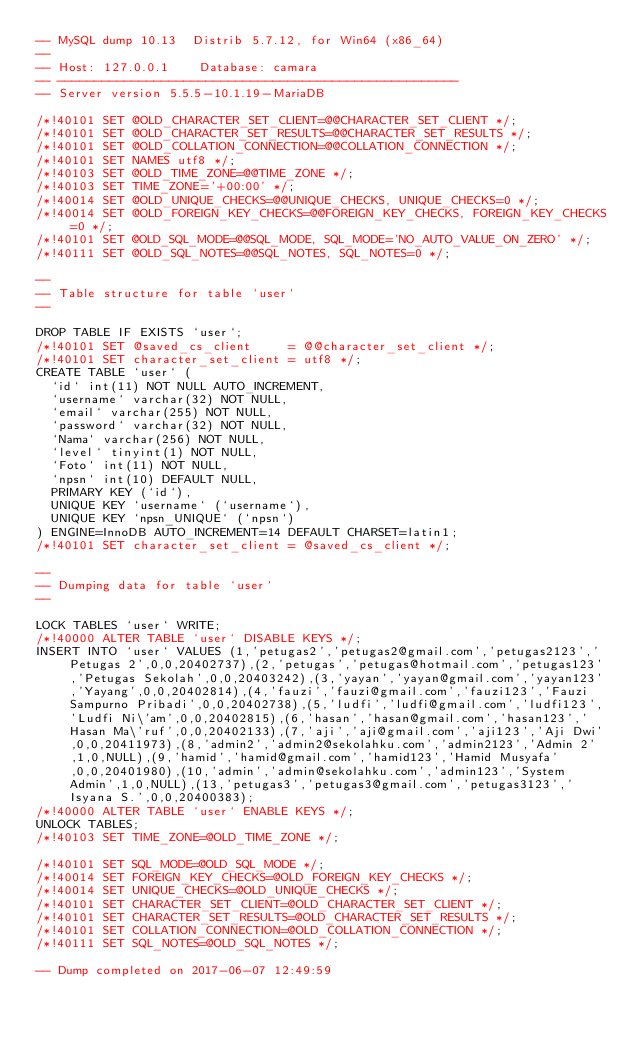<code> <loc_0><loc_0><loc_500><loc_500><_SQL_>-- MySQL dump 10.13  Distrib 5.7.12, for Win64 (x86_64)
--
-- Host: 127.0.0.1    Database: camara
-- ------------------------------------------------------
-- Server version	5.5.5-10.1.19-MariaDB

/*!40101 SET @OLD_CHARACTER_SET_CLIENT=@@CHARACTER_SET_CLIENT */;
/*!40101 SET @OLD_CHARACTER_SET_RESULTS=@@CHARACTER_SET_RESULTS */;
/*!40101 SET @OLD_COLLATION_CONNECTION=@@COLLATION_CONNECTION */;
/*!40101 SET NAMES utf8 */;
/*!40103 SET @OLD_TIME_ZONE=@@TIME_ZONE */;
/*!40103 SET TIME_ZONE='+00:00' */;
/*!40014 SET @OLD_UNIQUE_CHECKS=@@UNIQUE_CHECKS, UNIQUE_CHECKS=0 */;
/*!40014 SET @OLD_FOREIGN_KEY_CHECKS=@@FOREIGN_KEY_CHECKS, FOREIGN_KEY_CHECKS=0 */;
/*!40101 SET @OLD_SQL_MODE=@@SQL_MODE, SQL_MODE='NO_AUTO_VALUE_ON_ZERO' */;
/*!40111 SET @OLD_SQL_NOTES=@@SQL_NOTES, SQL_NOTES=0 */;

--
-- Table structure for table `user`
--

DROP TABLE IF EXISTS `user`;
/*!40101 SET @saved_cs_client     = @@character_set_client */;
/*!40101 SET character_set_client = utf8 */;
CREATE TABLE `user` (
  `id` int(11) NOT NULL AUTO_INCREMENT,
  `username` varchar(32) NOT NULL,
  `email` varchar(255) NOT NULL,
  `password` varchar(32) NOT NULL,
  `Nama` varchar(256) NOT NULL,
  `level` tinyint(1) NOT NULL,
  `Foto` int(11) NOT NULL,
  `npsn` int(10) DEFAULT NULL,
  PRIMARY KEY (`id`),
  UNIQUE KEY `username` (`username`),
  UNIQUE KEY `npsn_UNIQUE` (`npsn`)
) ENGINE=InnoDB AUTO_INCREMENT=14 DEFAULT CHARSET=latin1;
/*!40101 SET character_set_client = @saved_cs_client */;

--
-- Dumping data for table `user`
--

LOCK TABLES `user` WRITE;
/*!40000 ALTER TABLE `user` DISABLE KEYS */;
INSERT INTO `user` VALUES (1,'petugas2','petugas2@gmail.com','petugas2123','Petugas 2',0,0,20402737),(2,'petugas','petugas@hotmail.com','petugas123','Petugas Sekolah',0,0,20403242),(3,'yayan','yayan@gmail.com','yayan123','Yayang',0,0,20402814),(4,'fauzi','fauzi@gmail.com','fauzi123','Fauzi Sampurno Pribadi',0,0,20402738),(5,'ludfi','ludfi@gmail.com','ludfi123','Ludfi Ni\'am',0,0,20402815),(6,'hasan','hasan@gmail.com','hasan123','Hasan Ma\'ruf',0,0,20402133),(7,'aji','aji@gmail.com','aji123','Aji Dwi',0,0,20411973),(8,'admin2','admin2@sekolahku.com','admin2123','Admin 2',1,0,NULL),(9,'hamid','hamid@gmail.com','hamid123','Hamid Musyafa',0,0,20401980),(10,'admin','admin@sekolahku.com','admin123','System Admin',1,0,NULL),(13,'petugas3','petugas3@gmail.com','petugas3123','Isyana S.',0,0,20400383);
/*!40000 ALTER TABLE `user` ENABLE KEYS */;
UNLOCK TABLES;
/*!40103 SET TIME_ZONE=@OLD_TIME_ZONE */;

/*!40101 SET SQL_MODE=@OLD_SQL_MODE */;
/*!40014 SET FOREIGN_KEY_CHECKS=@OLD_FOREIGN_KEY_CHECKS */;
/*!40014 SET UNIQUE_CHECKS=@OLD_UNIQUE_CHECKS */;
/*!40101 SET CHARACTER_SET_CLIENT=@OLD_CHARACTER_SET_CLIENT */;
/*!40101 SET CHARACTER_SET_RESULTS=@OLD_CHARACTER_SET_RESULTS */;
/*!40101 SET COLLATION_CONNECTION=@OLD_COLLATION_CONNECTION */;
/*!40111 SET SQL_NOTES=@OLD_SQL_NOTES */;

-- Dump completed on 2017-06-07 12:49:59
</code> 